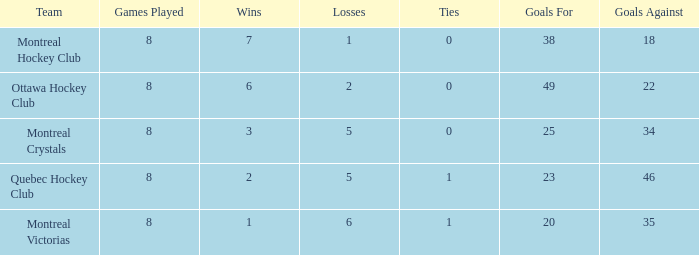For montreal victorias, when they have played more than 8 games, what is the average ties count? None. 